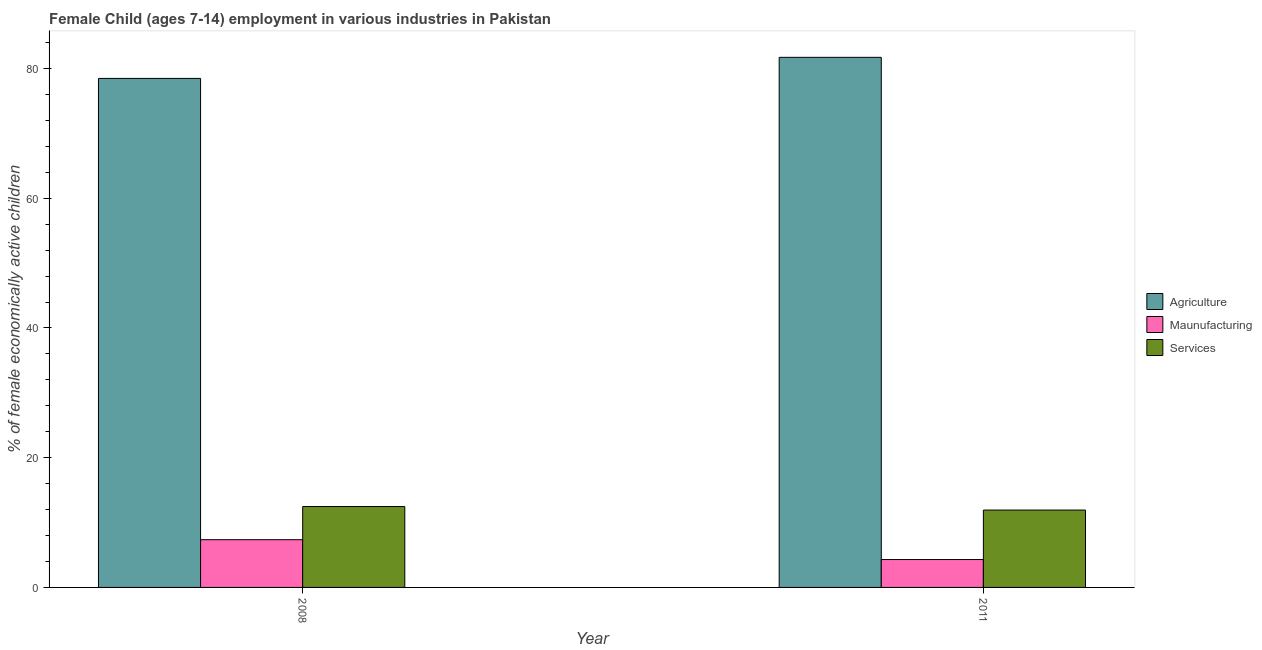How many different coloured bars are there?
Provide a short and direct response. 3. Are the number of bars on each tick of the X-axis equal?
Give a very brief answer. Yes. What is the label of the 2nd group of bars from the left?
Ensure brevity in your answer.  2011. In how many cases, is the number of bars for a given year not equal to the number of legend labels?
Offer a very short reply. 0. What is the percentage of economically active children in services in 2008?
Ensure brevity in your answer.  12.47. Across all years, what is the maximum percentage of economically active children in agriculture?
Make the answer very short. 81.73. What is the total percentage of economically active children in agriculture in the graph?
Give a very brief answer. 160.21. What is the difference between the percentage of economically active children in services in 2008 and that in 2011?
Give a very brief answer. 0.54. What is the difference between the percentage of economically active children in services in 2011 and the percentage of economically active children in agriculture in 2008?
Your answer should be very brief. -0.54. What is the average percentage of economically active children in manufacturing per year?
Your answer should be compact. 5.83. In the year 2008, what is the difference between the percentage of economically active children in services and percentage of economically active children in agriculture?
Your response must be concise. 0. What is the ratio of the percentage of economically active children in agriculture in 2008 to that in 2011?
Ensure brevity in your answer.  0.96. What does the 1st bar from the left in 2008 represents?
Keep it short and to the point. Agriculture. What does the 3rd bar from the right in 2008 represents?
Ensure brevity in your answer.  Agriculture. Are all the bars in the graph horizontal?
Ensure brevity in your answer.  No. Does the graph contain grids?
Offer a terse response. No. How are the legend labels stacked?
Give a very brief answer. Vertical. What is the title of the graph?
Your answer should be very brief. Female Child (ages 7-14) employment in various industries in Pakistan. What is the label or title of the Y-axis?
Keep it short and to the point. % of female economically active children. What is the % of female economically active children in Agriculture in 2008?
Offer a very short reply. 78.48. What is the % of female economically active children in Maunufacturing in 2008?
Offer a terse response. 7.36. What is the % of female economically active children in Services in 2008?
Provide a succinct answer. 12.47. What is the % of female economically active children of Agriculture in 2011?
Offer a terse response. 81.73. What is the % of female economically active children in Maunufacturing in 2011?
Your answer should be very brief. 4.3. What is the % of female economically active children in Services in 2011?
Your answer should be very brief. 11.93. Across all years, what is the maximum % of female economically active children in Agriculture?
Offer a very short reply. 81.73. Across all years, what is the maximum % of female economically active children in Maunufacturing?
Ensure brevity in your answer.  7.36. Across all years, what is the maximum % of female economically active children of Services?
Keep it short and to the point. 12.47. Across all years, what is the minimum % of female economically active children of Agriculture?
Provide a short and direct response. 78.48. Across all years, what is the minimum % of female economically active children in Services?
Your answer should be compact. 11.93. What is the total % of female economically active children in Agriculture in the graph?
Offer a terse response. 160.21. What is the total % of female economically active children in Maunufacturing in the graph?
Ensure brevity in your answer.  11.66. What is the total % of female economically active children of Services in the graph?
Keep it short and to the point. 24.4. What is the difference between the % of female economically active children of Agriculture in 2008 and that in 2011?
Make the answer very short. -3.25. What is the difference between the % of female economically active children of Maunufacturing in 2008 and that in 2011?
Provide a short and direct response. 3.06. What is the difference between the % of female economically active children in Services in 2008 and that in 2011?
Ensure brevity in your answer.  0.54. What is the difference between the % of female economically active children of Agriculture in 2008 and the % of female economically active children of Maunufacturing in 2011?
Provide a short and direct response. 74.18. What is the difference between the % of female economically active children in Agriculture in 2008 and the % of female economically active children in Services in 2011?
Offer a very short reply. 66.55. What is the difference between the % of female economically active children in Maunufacturing in 2008 and the % of female economically active children in Services in 2011?
Your answer should be very brief. -4.57. What is the average % of female economically active children of Agriculture per year?
Give a very brief answer. 80.11. What is the average % of female economically active children of Maunufacturing per year?
Your answer should be very brief. 5.83. What is the average % of female economically active children in Services per year?
Your answer should be very brief. 12.2. In the year 2008, what is the difference between the % of female economically active children of Agriculture and % of female economically active children of Maunufacturing?
Your answer should be very brief. 71.12. In the year 2008, what is the difference between the % of female economically active children in Agriculture and % of female economically active children in Services?
Your answer should be very brief. 66.01. In the year 2008, what is the difference between the % of female economically active children of Maunufacturing and % of female economically active children of Services?
Your answer should be compact. -5.11. In the year 2011, what is the difference between the % of female economically active children in Agriculture and % of female economically active children in Maunufacturing?
Your response must be concise. 77.43. In the year 2011, what is the difference between the % of female economically active children of Agriculture and % of female economically active children of Services?
Your answer should be very brief. 69.8. In the year 2011, what is the difference between the % of female economically active children in Maunufacturing and % of female economically active children in Services?
Provide a short and direct response. -7.63. What is the ratio of the % of female economically active children in Agriculture in 2008 to that in 2011?
Provide a short and direct response. 0.96. What is the ratio of the % of female economically active children in Maunufacturing in 2008 to that in 2011?
Offer a very short reply. 1.71. What is the ratio of the % of female economically active children of Services in 2008 to that in 2011?
Offer a terse response. 1.05. What is the difference between the highest and the second highest % of female economically active children of Agriculture?
Offer a terse response. 3.25. What is the difference between the highest and the second highest % of female economically active children in Maunufacturing?
Your answer should be compact. 3.06. What is the difference between the highest and the second highest % of female economically active children in Services?
Make the answer very short. 0.54. What is the difference between the highest and the lowest % of female economically active children in Maunufacturing?
Provide a succinct answer. 3.06. What is the difference between the highest and the lowest % of female economically active children of Services?
Your response must be concise. 0.54. 